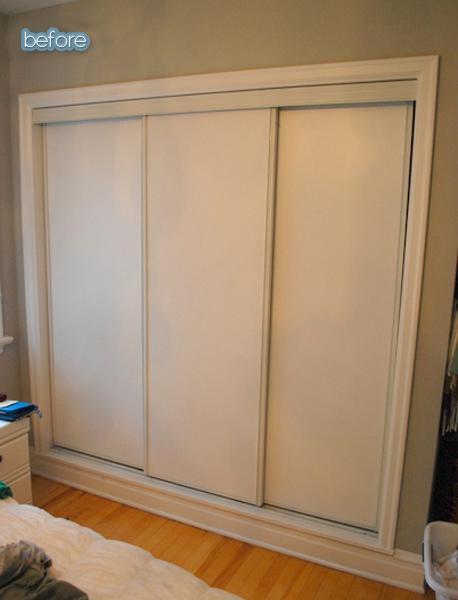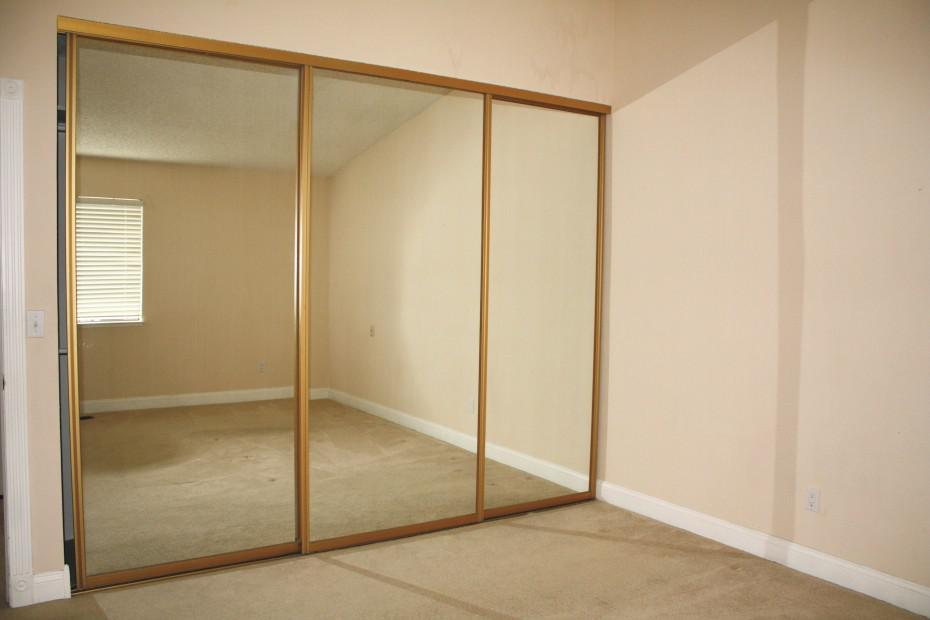The first image is the image on the left, the second image is the image on the right. For the images shown, is this caption "An image shows a three-section white sliding door unit with round dark handles." true? Answer yes or no. No. The first image is the image on the left, the second image is the image on the right. For the images displayed, is the sentence "One three panel door has visible hardware on each door and a second three panel door has a contrasting middle band and no visible hardware." factually correct? Answer yes or no. No. 